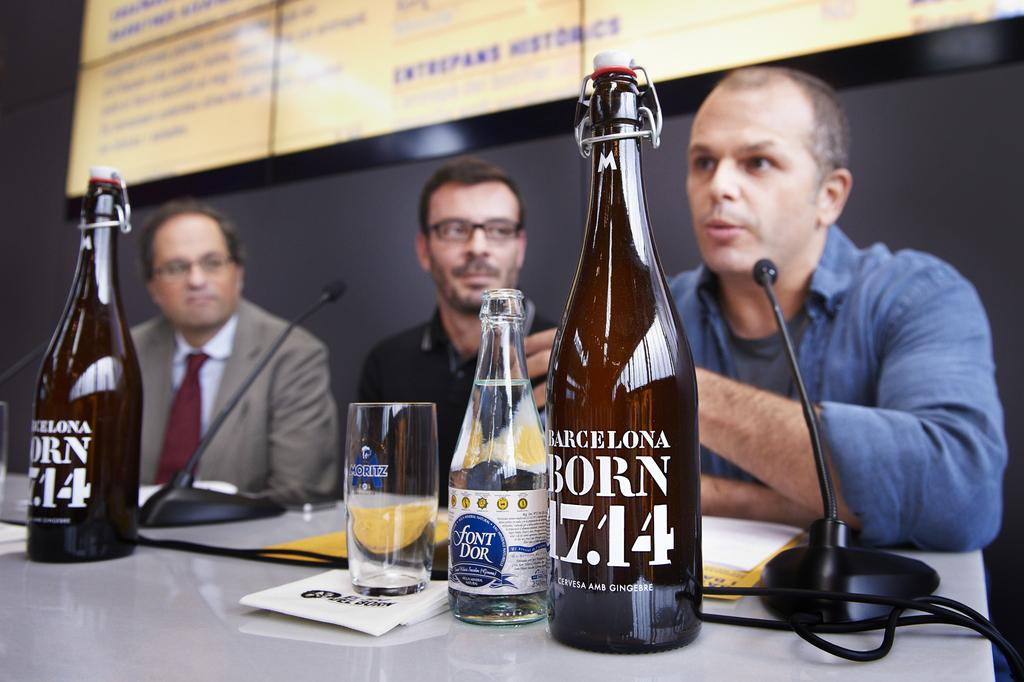<image>
Summarize the visual content of the image. A bottle in front of a man has the number 17.14 on it. 